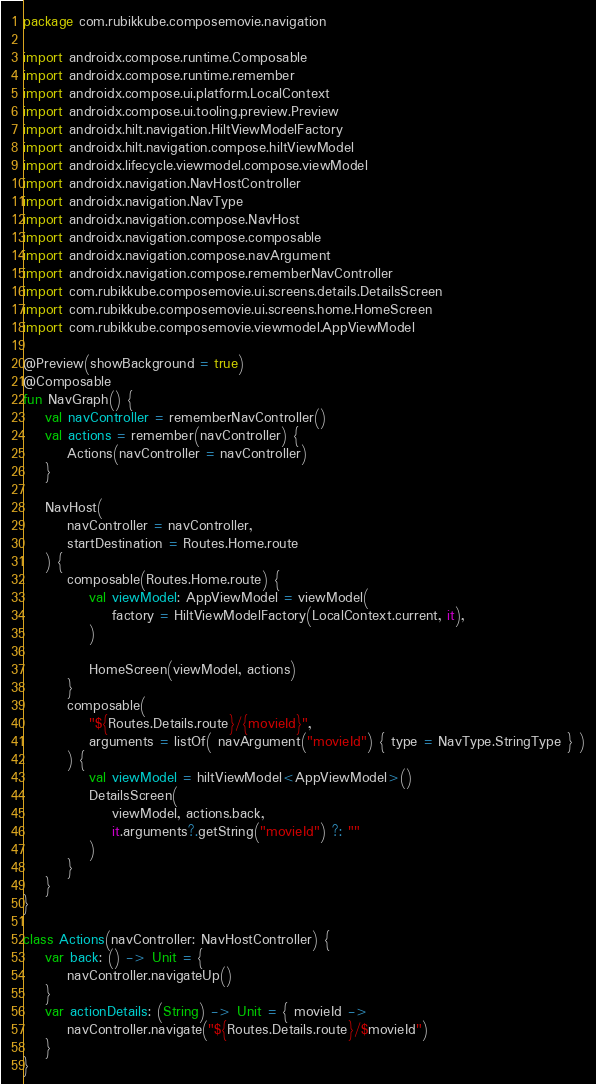<code> <loc_0><loc_0><loc_500><loc_500><_Kotlin_>package com.rubikkube.composemovie.navigation

import androidx.compose.runtime.Composable
import androidx.compose.runtime.remember
import androidx.compose.ui.platform.LocalContext
import androidx.compose.ui.tooling.preview.Preview
import androidx.hilt.navigation.HiltViewModelFactory
import androidx.hilt.navigation.compose.hiltViewModel
import androidx.lifecycle.viewmodel.compose.viewModel
import androidx.navigation.NavHostController
import androidx.navigation.NavType
import androidx.navigation.compose.NavHost
import androidx.navigation.compose.composable
import androidx.navigation.compose.navArgument
import androidx.navigation.compose.rememberNavController
import com.rubikkube.composemovie.ui.screens.details.DetailsScreen
import com.rubikkube.composemovie.ui.screens.home.HomeScreen
import com.rubikkube.composemovie.viewmodel.AppViewModel

@Preview(showBackground = true)
@Composable
fun NavGraph() {
    val navController = rememberNavController()
    val actions = remember(navController) {
        Actions(navController = navController)
    }

    NavHost(
        navController = navController,
        startDestination = Routes.Home.route
    ) {
        composable(Routes.Home.route) {
            val viewModel: AppViewModel = viewModel(
                factory = HiltViewModelFactory(LocalContext.current, it),
            )

            HomeScreen(viewModel, actions)
        }
        composable(
            "${Routes.Details.route}/{movieId}",
            arguments = listOf( navArgument("movieId") { type = NavType.StringType } )
        ) {
            val viewModel = hiltViewModel<AppViewModel>()
            DetailsScreen(
                viewModel, actions.back,
                it.arguments?.getString("movieId") ?: ""
            )
        }
    }
}

class Actions(navController: NavHostController) {
    var back: () -> Unit = {
        navController.navigateUp()
    }
    var actionDetails: (String) -> Unit = { movieId ->
        navController.navigate("${Routes.Details.route}/$movieId")
    }
}</code> 